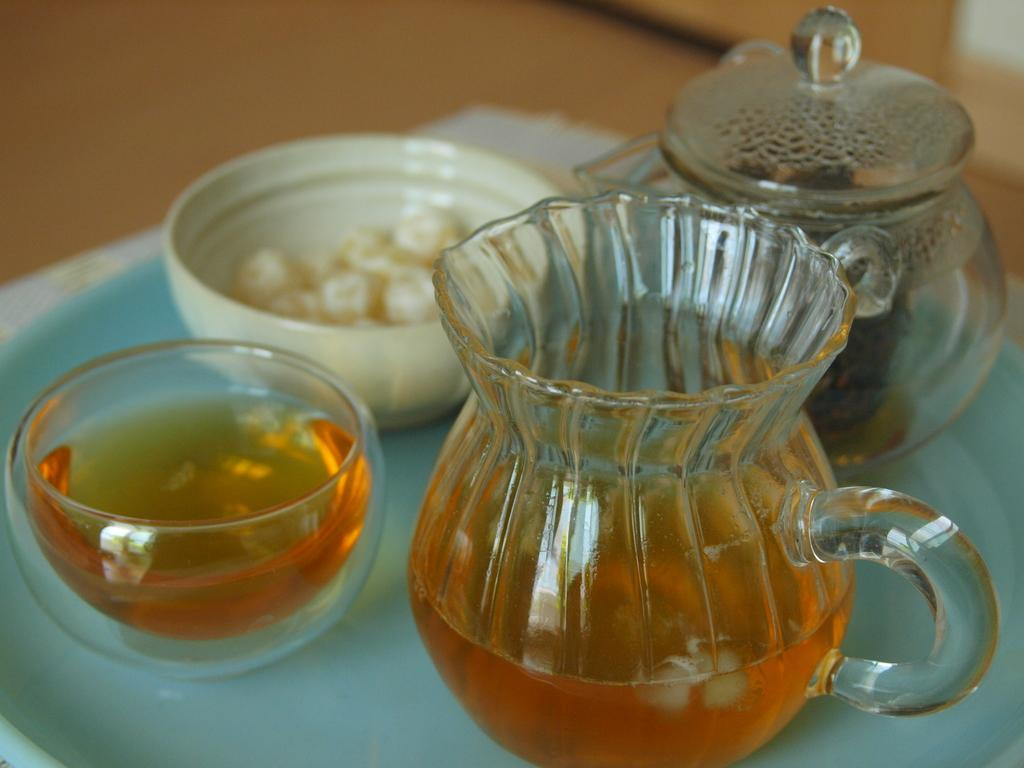What is present on the plate in the image? There are two bowls and two glass jugs on the plate in the image. What is inside the bowls? There is a drink in the bowls. What is inside the jugs? There is a drink in the jugs. Can you describe the background of the image? The background of the image is blurry. What knowledge can be gained from the number of days depicted in the image? There is no reference to days or any numerical information in the image, so it is not possible to answer that question. 